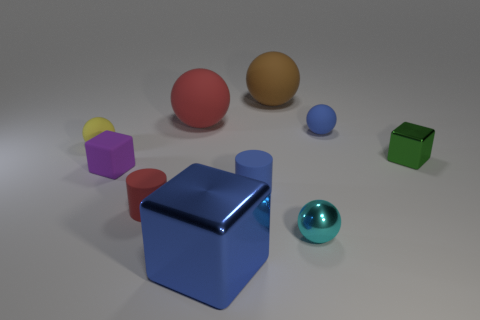Can you describe the texture of the objects visible in the image? Certainly! The large blue cube appears to have a smooth, glossy finish, while the green cube looks matte. The spheres and cylinders have a smooth surface as well, and the small blue sphere in particular seems to have a reflective, metallic texture. 